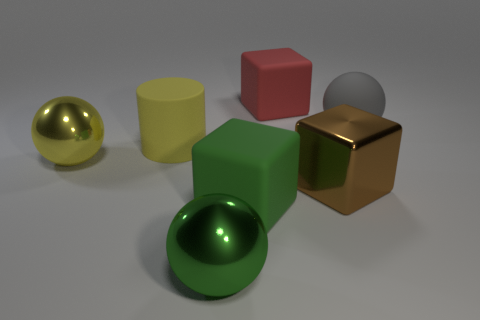Is there any other thing that is the same color as the large rubber sphere?
Keep it short and to the point. No. What number of big balls are both behind the big yellow rubber thing and left of the yellow matte cylinder?
Provide a short and direct response. 0. There is a matte cube in front of the big brown metal object; is it the same size as the cube that is behind the large gray matte sphere?
Give a very brief answer. Yes. How many things are green objects to the left of the green cube or tiny blue balls?
Make the answer very short. 1. There is a big yellow object in front of the yellow rubber cylinder; what is its material?
Make the answer very short. Metal. What is the large gray sphere made of?
Provide a short and direct response. Rubber. What is the large cube left of the big block behind the big ball that is to the right of the large green metal ball made of?
Your response must be concise. Rubber. Is there anything else that has the same material as the large brown cube?
Ensure brevity in your answer.  Yes. Does the gray rubber object have the same size as the matte thing behind the gray ball?
Give a very brief answer. Yes. How many objects are large cubes in front of the red rubber block or large objects in front of the red cube?
Offer a terse response. 6. 